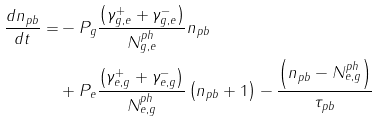<formula> <loc_0><loc_0><loc_500><loc_500>\frac { { d n _ { p b } } } { d t } = & - P _ { g } \frac { { \left ( { \gamma _ { g , e } ^ { + } + \gamma _ { g , e } ^ { - } } \right ) } } { { N _ { g , e } ^ { p h } } } n _ { p b } \\ & + P _ { e } \frac { { \left ( { \gamma _ { e , g } ^ { + } + \gamma _ { e , g } ^ { - } } \right ) } } { { N _ { e , g } ^ { p h } } } \left ( { n _ { p b } + 1 } \right ) - \frac { { \left ( { n _ { p b } - N _ { e , g } ^ { p h } } \right ) } } { { \tau } _ { p b } } \\</formula> 